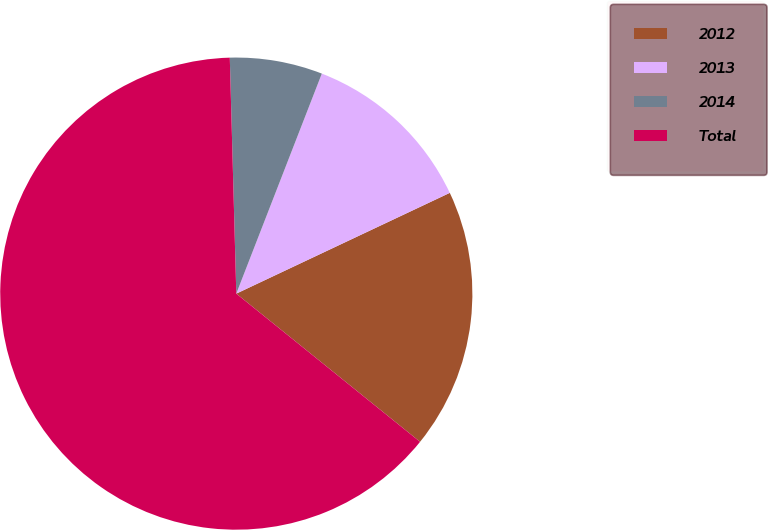<chart> <loc_0><loc_0><loc_500><loc_500><pie_chart><fcel>2012<fcel>2013<fcel>2014<fcel>Total<nl><fcel>17.82%<fcel>12.08%<fcel>6.34%<fcel>63.76%<nl></chart> 